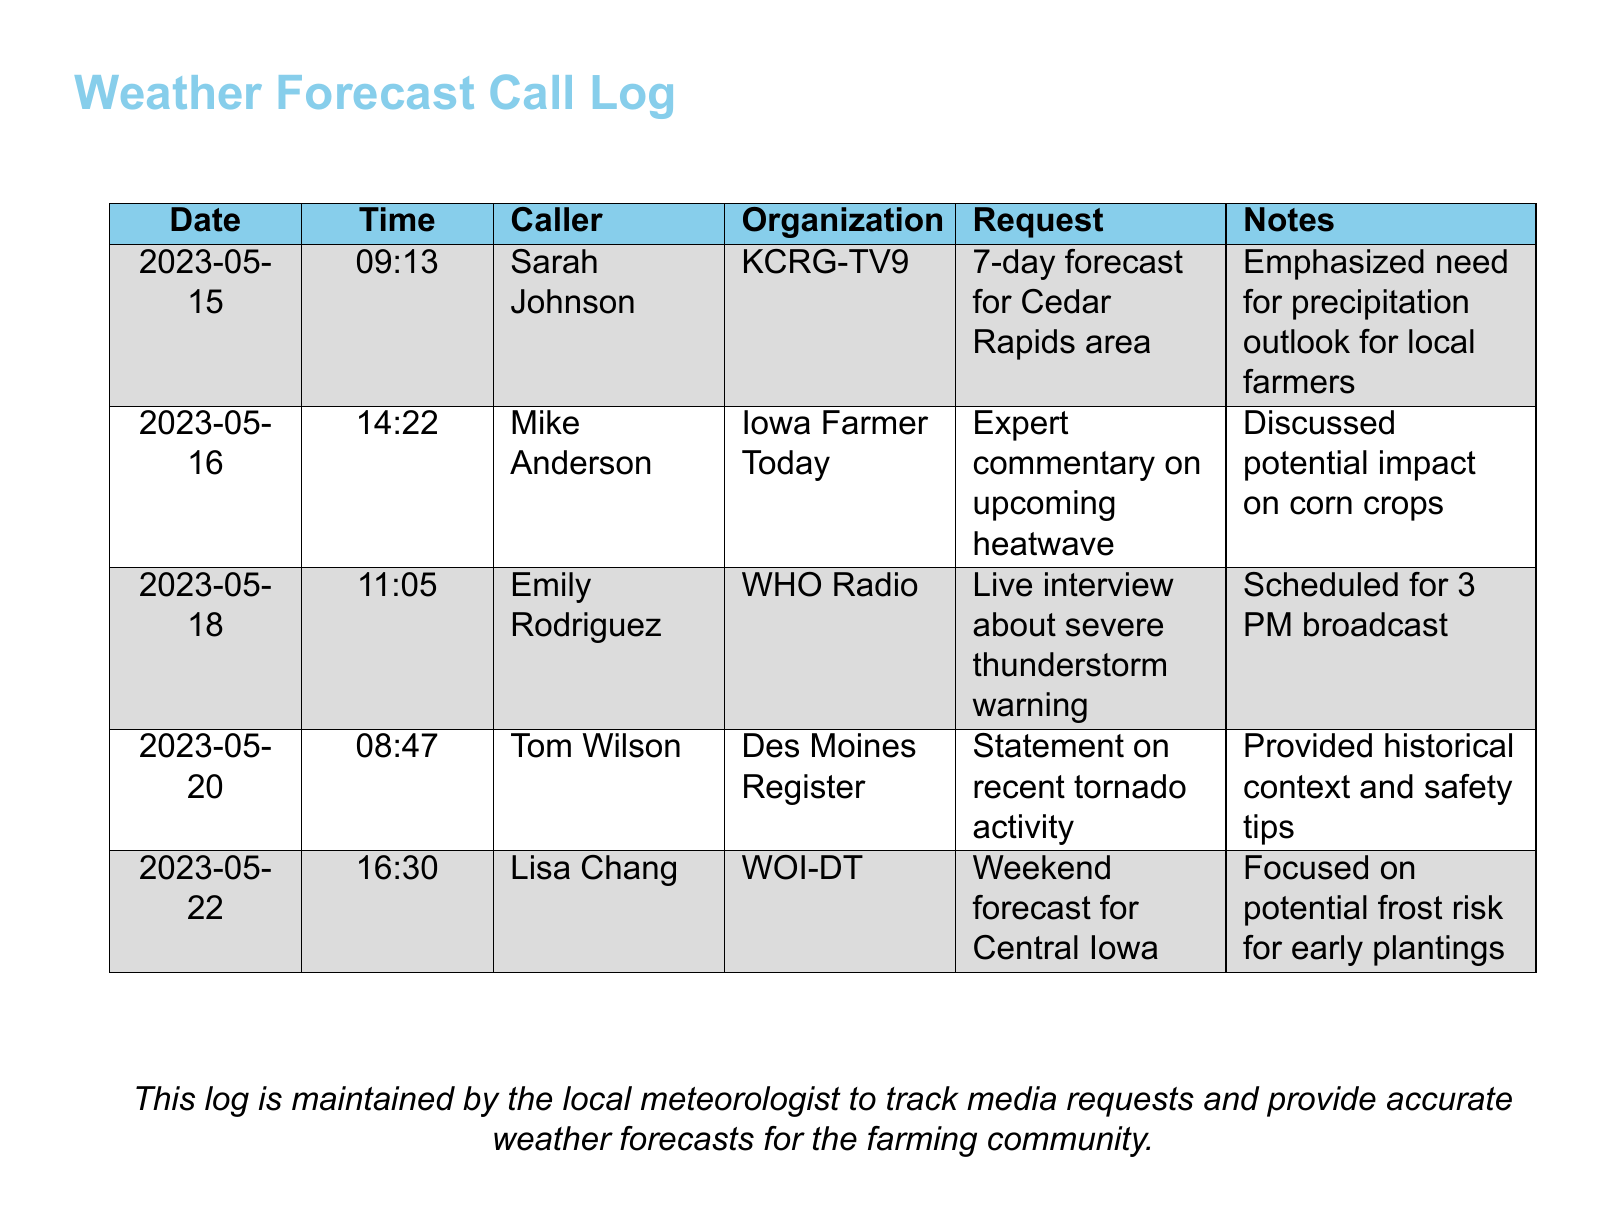What is the date of the first call logged? The date of the first call is the earliest date recorded in the log, which is 2023-05-15.
Answer: 2023-05-15 Who called from KCRG-TV9? The caller from KCRG-TV9 is Sarah Johnson.
Answer: Sarah Johnson What was the request from Iowa Farmer Today? The request made by Iowa Farmer Today was for expert commentary on an upcoming heatwave.
Answer: Expert commentary on upcoming heatwave What time was the call from WHO Radio? The call from WHO Radio came in at 11:05 on 2023-05-18.
Answer: 11:05 What was a specific topic discussed with Tom Wilson from Des Moines Register? Tom Wilson's call discussed recent tornado activity.
Answer: Recent tornado activity How many calls are logged in total? The total number of calls can be counted by looking at the number of rows representing calls in the log. There are five recorded calls.
Answer: 5 What was emphasized in Sarah Johnson's call? Sarah Johnson emphasized the need for a precipitation outlook for local farmers.
Answer: Need for precipitation outlook Which organization scheduled a live interview about severe thunderstorm warnings? The organization that scheduled the live interview is WHO Radio.
Answer: WHO Radio What specific risk was focused on in the weekend forecast for Central Iowa? The specific risk highlighted was the potential frost risk for early plantings.
Answer: Potential frost risk 